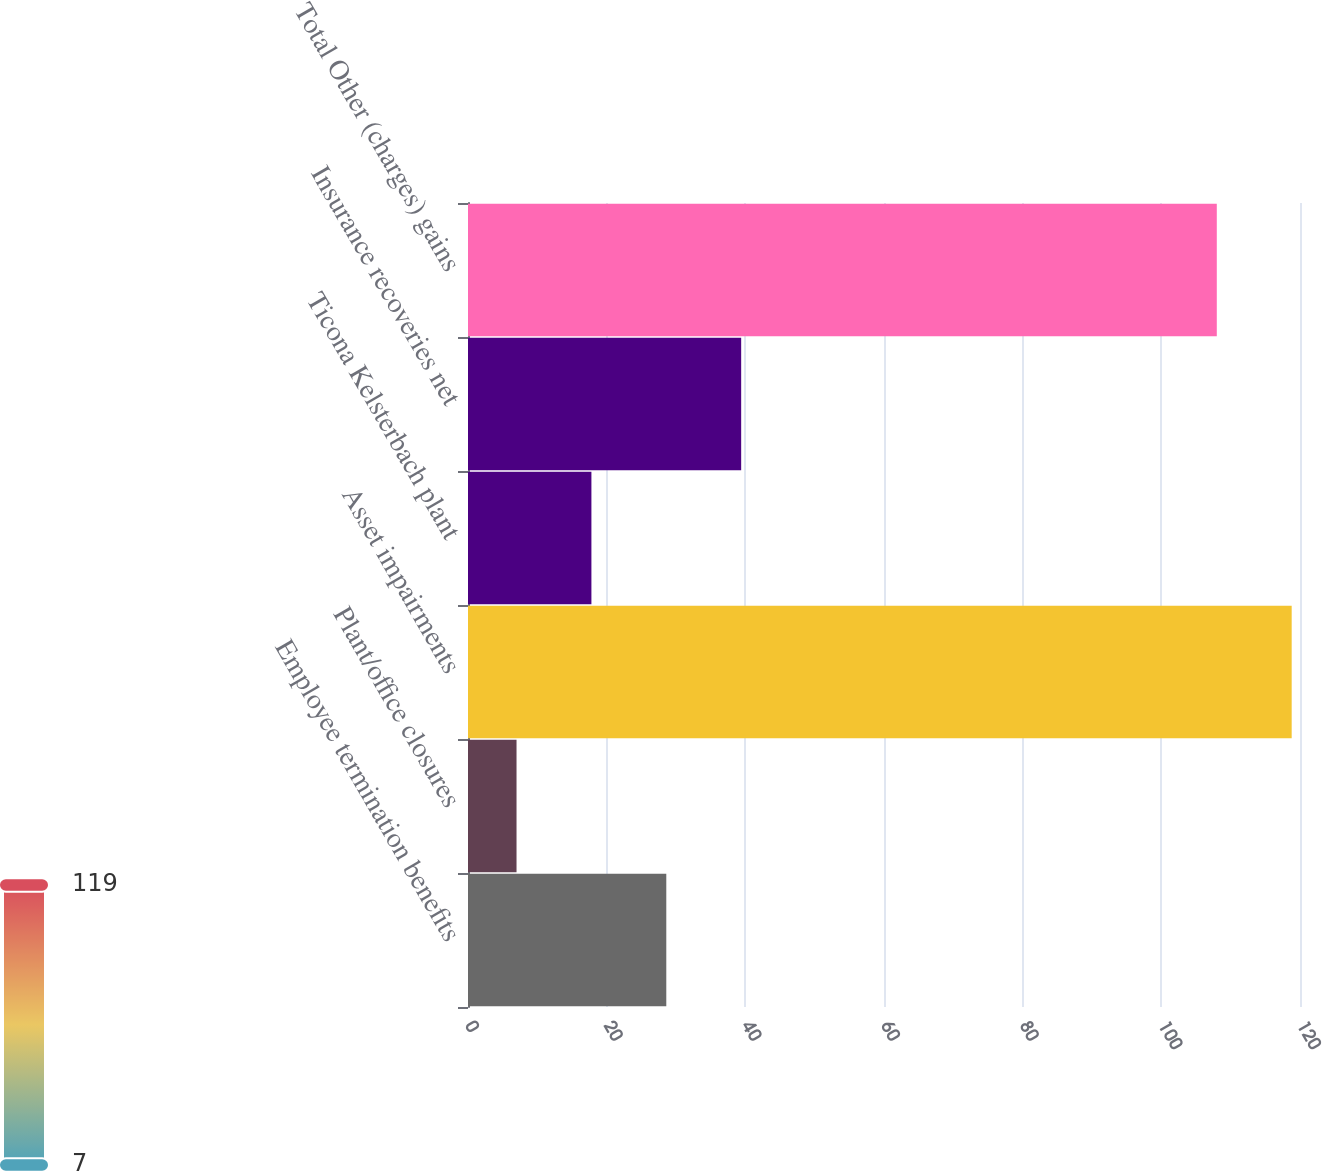Convert chart. <chart><loc_0><loc_0><loc_500><loc_500><bar_chart><fcel>Employee termination benefits<fcel>Plant/office closures<fcel>Asset impairments<fcel>Ticona Kelsterbach plant<fcel>Insurance recoveries net<fcel>Total Other (charges) gains<nl><fcel>28.6<fcel>7<fcel>118.8<fcel>17.8<fcel>39.4<fcel>108<nl></chart> 